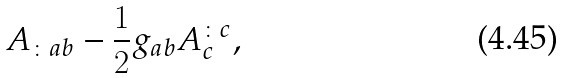<formula> <loc_0><loc_0><loc_500><loc_500>A _ { \colon a b } - \frac { 1 } { 2 } g _ { a b } A ^ { \colon c } _ { c } ,</formula> 